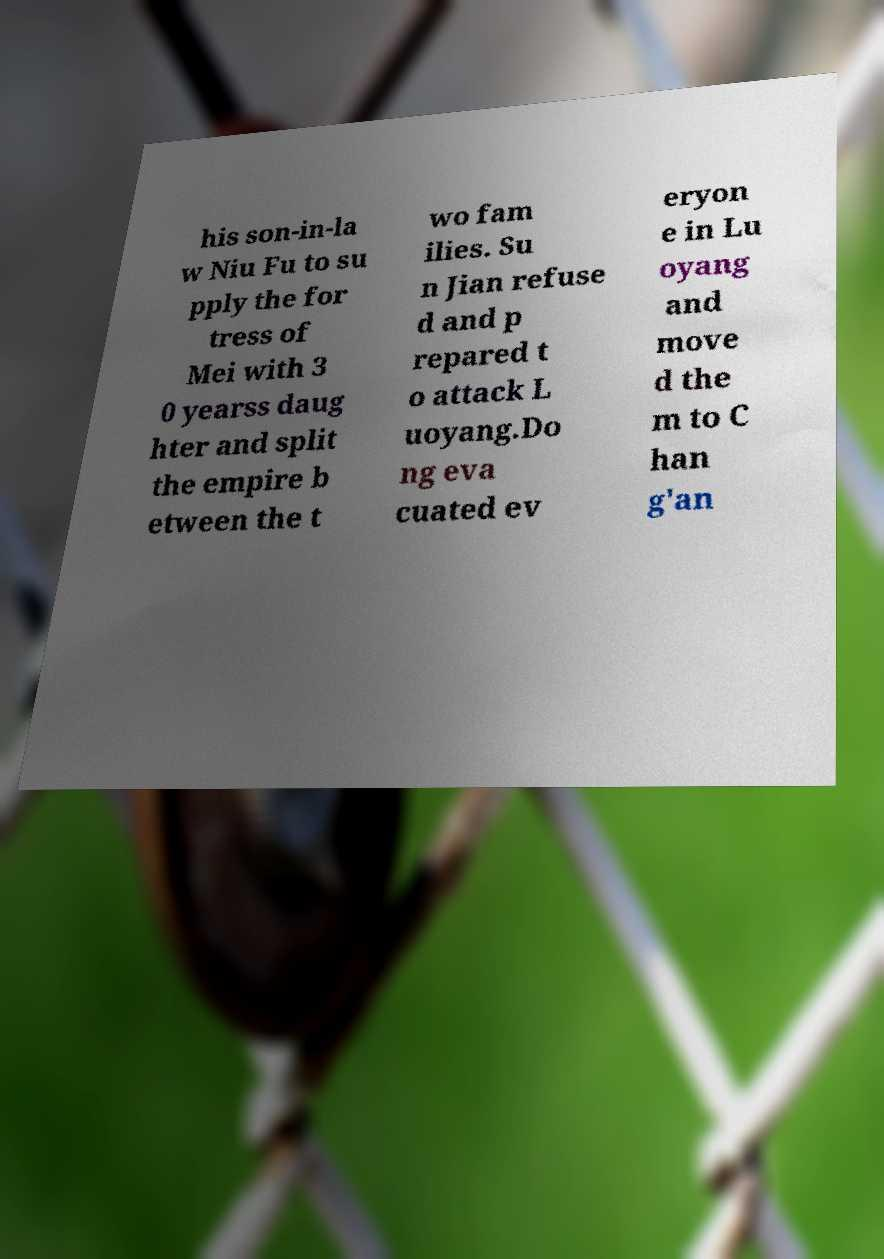There's text embedded in this image that I need extracted. Can you transcribe it verbatim? his son-in-la w Niu Fu to su pply the for tress of Mei with 3 0 yearss daug hter and split the empire b etween the t wo fam ilies. Su n Jian refuse d and p repared t o attack L uoyang.Do ng eva cuated ev eryon e in Lu oyang and move d the m to C han g'an 